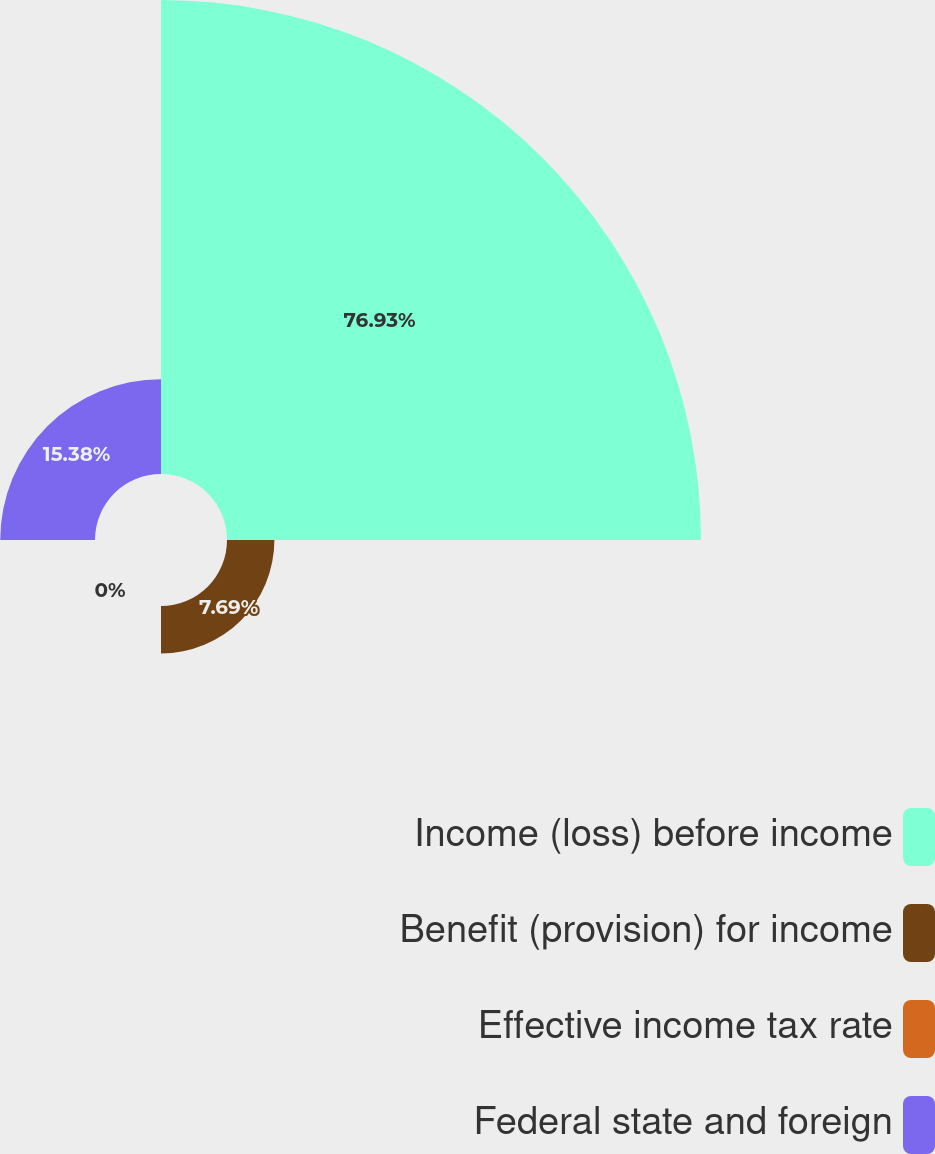Convert chart to OTSL. <chart><loc_0><loc_0><loc_500><loc_500><pie_chart><fcel>Income (loss) before income<fcel>Benefit (provision) for income<fcel>Effective income tax rate<fcel>Federal state and foreign<nl><fcel>76.92%<fcel>7.69%<fcel>0.0%<fcel>15.38%<nl></chart> 